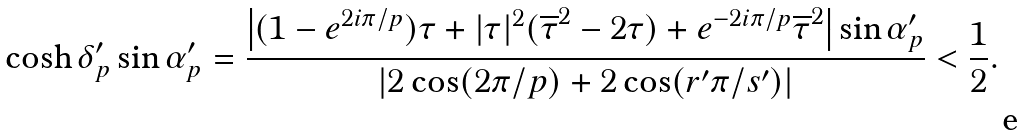Convert formula to latex. <formula><loc_0><loc_0><loc_500><loc_500>\cosh \delta ^ { \prime } _ { p } \sin \alpha ^ { \prime } _ { p } = \frac { \left | ( 1 - e ^ { 2 i \pi / p } ) \tau + | \tau | ^ { 2 } ( \overline { \tau } ^ { 2 } - 2 \tau ) + e ^ { - 2 i \pi / p } \overline { \tau } ^ { 2 } \right | \sin \alpha ^ { \prime } _ { p } } { \left | 2 \cos ( 2 \pi / p ) + 2 \cos ( r ^ { \prime } \pi / s ^ { \prime } ) \right | } < \frac { 1 } { 2 } .</formula> 